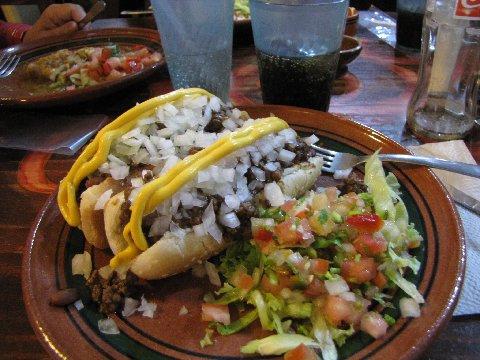How many items of silverware are there?
Give a very brief answer. 1. Is this a healthy meal?
Concise answer only. No. What is the cup made of?
Keep it brief. Plastic. Is this a party snack?
Concise answer only. No. What beverage is in the glass?
Short answer required. Soda. Is this a healthy dinner?
Answer briefly. No. Does this diner like onions?
Concise answer only. Yes. Are there French fries on the plate?
Give a very brief answer. No. Is there a spoon on the plate?
Be succinct. No. What is the yellow sauce on top of the food?
Concise answer only. Mustard. What kind of bottle is to the right?
Keep it brief. Soda. 